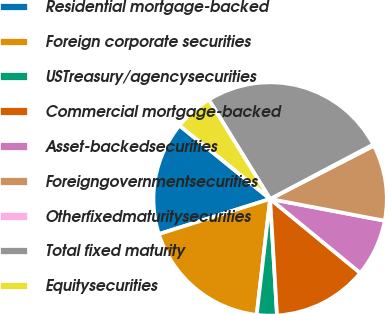Convert chart. <chart><loc_0><loc_0><loc_500><loc_500><pie_chart><fcel>Residential mortgage-backed<fcel>Foreign corporate securities<fcel>USTreasury/agencysecurities<fcel>Commercial mortgage-backed<fcel>Asset-backedsecurities<fcel>Foreigngovernmentsecurities<fcel>Otherfixedmaturitysecurities<fcel>Total fixed maturity<fcel>Equitysecurities<nl><fcel>15.71%<fcel>18.3%<fcel>2.78%<fcel>13.12%<fcel>7.95%<fcel>10.54%<fcel>0.19%<fcel>26.06%<fcel>5.36%<nl></chart> 